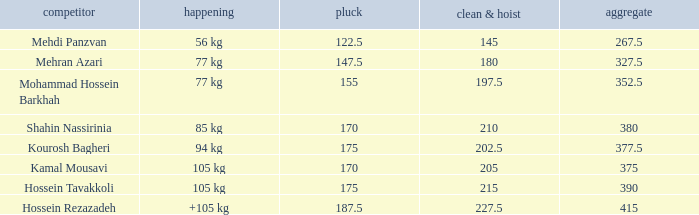What is the lowest total that had less than 170 snatches, 56 kg events and less than 145 clean & jerk? None. 